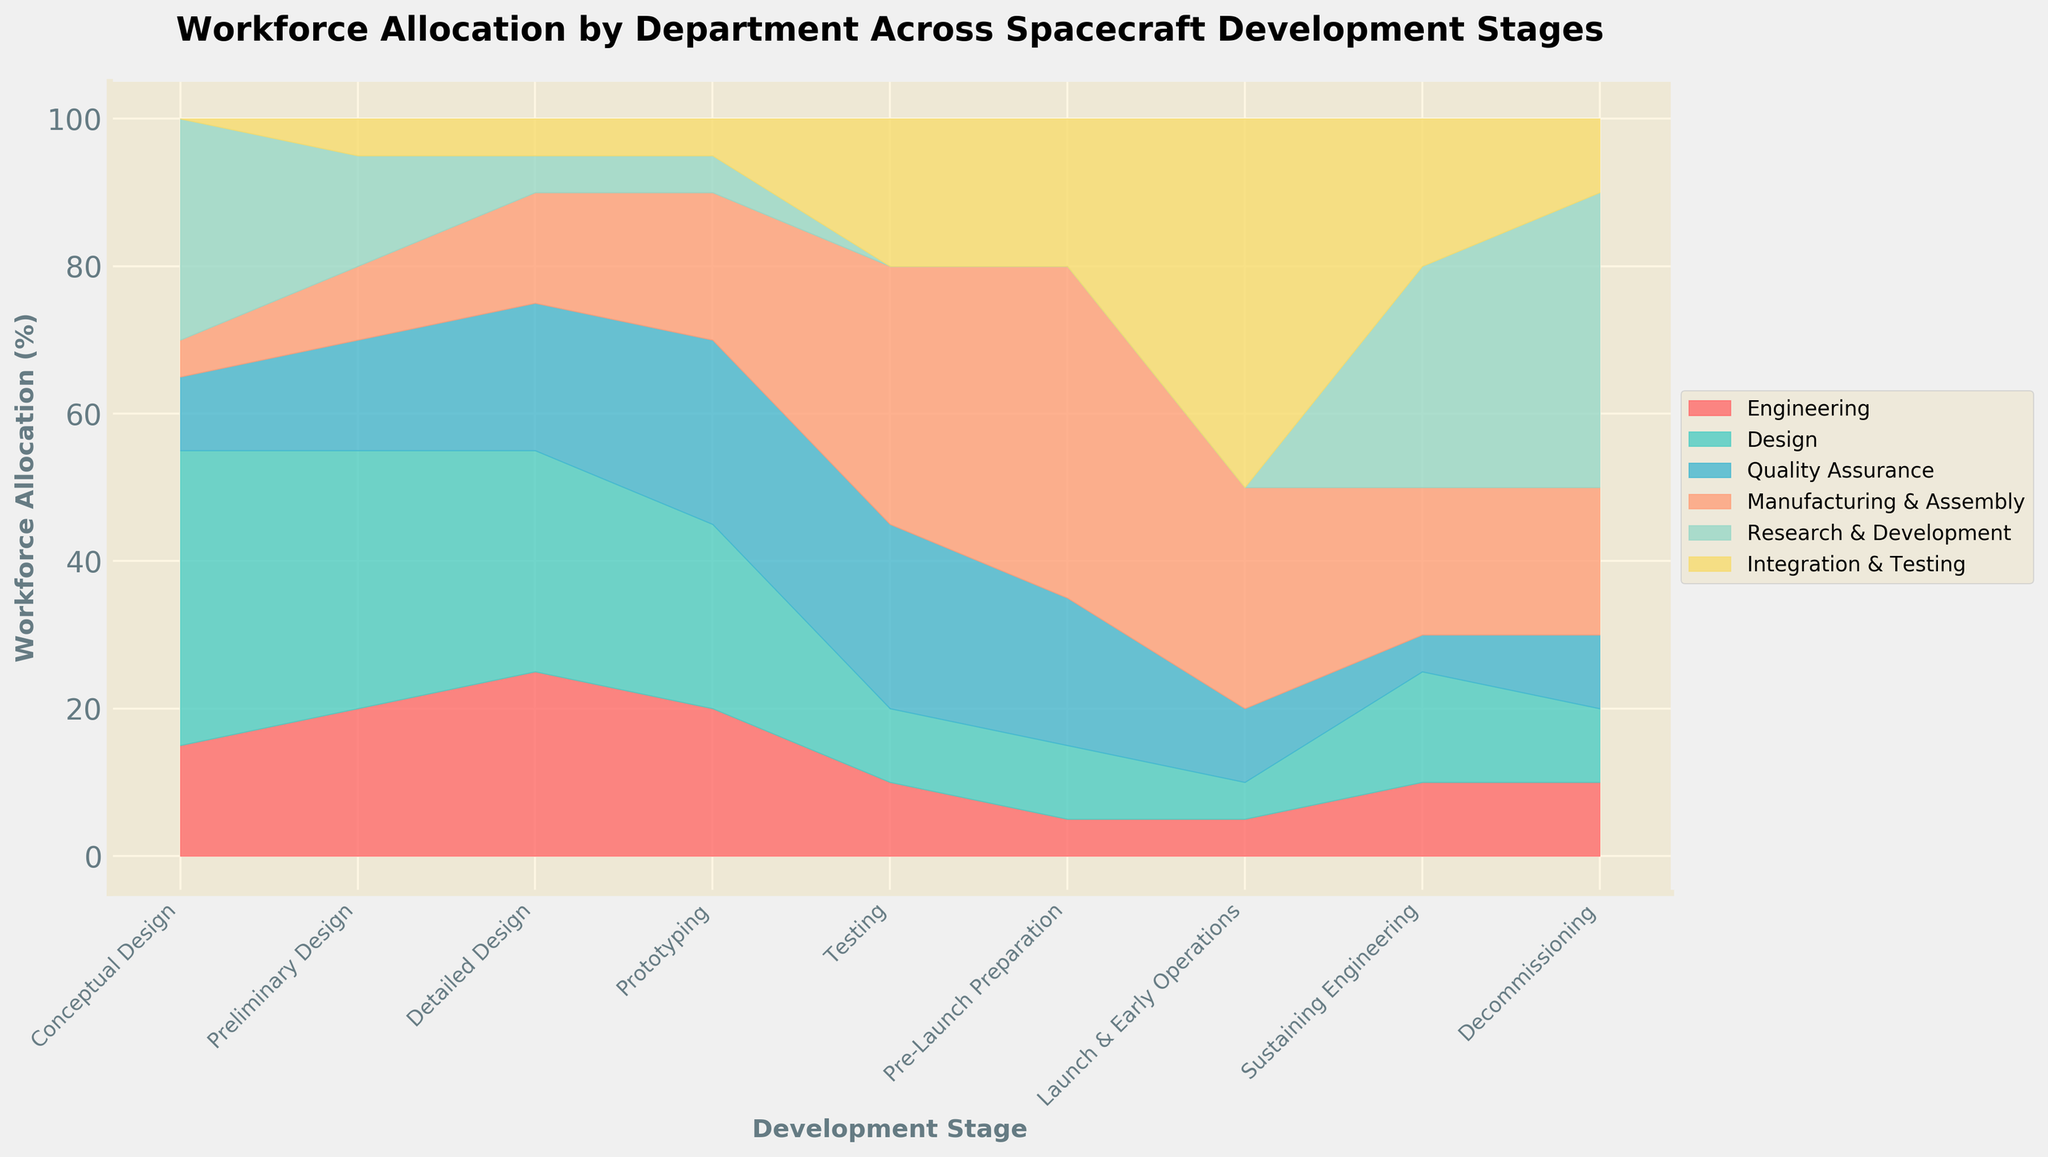What's the title of the figure? The title of the figure is clearly stated at the top of the plot. It's in bold and larger font size.
Answer: Workforce Allocation by Department Across Spacecraft Development Stages Which development stage has the highest workforce allocation in the 'Manufacturing & Assembly' department? To find this, look at the segment corresponding to 'Manufacturing & Assembly' across all stages and identify which one is the tallest.
Answer: Pre-Launch Preparation How does the workforce allocation in the 'Quality Assurance' department change from 'Conceptual Design' to 'Testing'? Observe the height of the 'Quality Assurance' section for the stages 'Conceptual Design' and 'Testing'. Calculate the difference.
Answer: It increases from 10% to 25% What's the average workforce allocation percentage for 'Design' from 'Conceptual Design' to 'Prototyping'? Sum the workforce percentages allocated to 'Design' over the stages 'Conceptual Design', 'Preliminary Design', 'Detailed Design', and 'Prototyping', and then divide by the number of stages (4).
Answer: 32.5% Compare the workforce allocation in 'Engineering' during 'Launch & Early Operations' and 'Sustaining Engineering'. Which stage has a higher allocation? Look at the 'Engineering' segment height in 'Launch & Early Operations' and 'Sustaining Engineering'. The higher segment indicates a higher allocation.
Answer: Sustaining Engineering What happens to the 'Research & Development' workforce allocation during 'Pre-Launch Preparation' and 'Launch & Early Operations'? Identify the 'Research & Development' section in both stages. Note the change in its height (or visibility).
Answer: It drops to 0% during both stages During which stage does the 'Integration & Testing' workforce allocation reach its peak? Scan through all stages and identify where the 'Integration & Testing' section is tallest.
Answer: Launch & Early Operations Which departments have a non-zero workforce allocation in the 'Conceptual Design' stage and what are their respective percentages? Identify the segments in the 'Conceptual Design' stage that are visibly non-zero, and read off their values.
Answer: Engineering (15%), Design (40%), Quality Assurance (10%), Manufacturing & Assembly (5%), Research & Development (30%) What trend can you observe in the 'Detailed Design' stage for 'Engineering' and 'Quality Assurance'? Note the changes in height of the 'Engineering' and 'Quality Assurance' segments. Describe the variation.
Answer: 'Engineering' increases to 25%, while 'Quality Assurance' increases to 20% What's the total workforce allocation for 'Integration & Testing' in all stages combined? Sum the 'Integration & Testing' percentages over all stages. Adding them gives 5 + 5 + 5 + 5 + 20 + 20 + 50 + 20 + 10.
Answer: 140% 